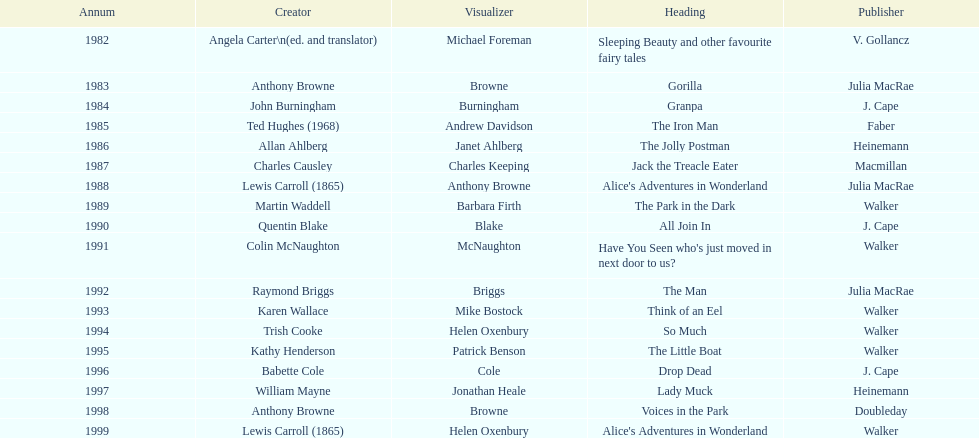How many times has anthony browne won an kurt maschler award for illustration? 3. 